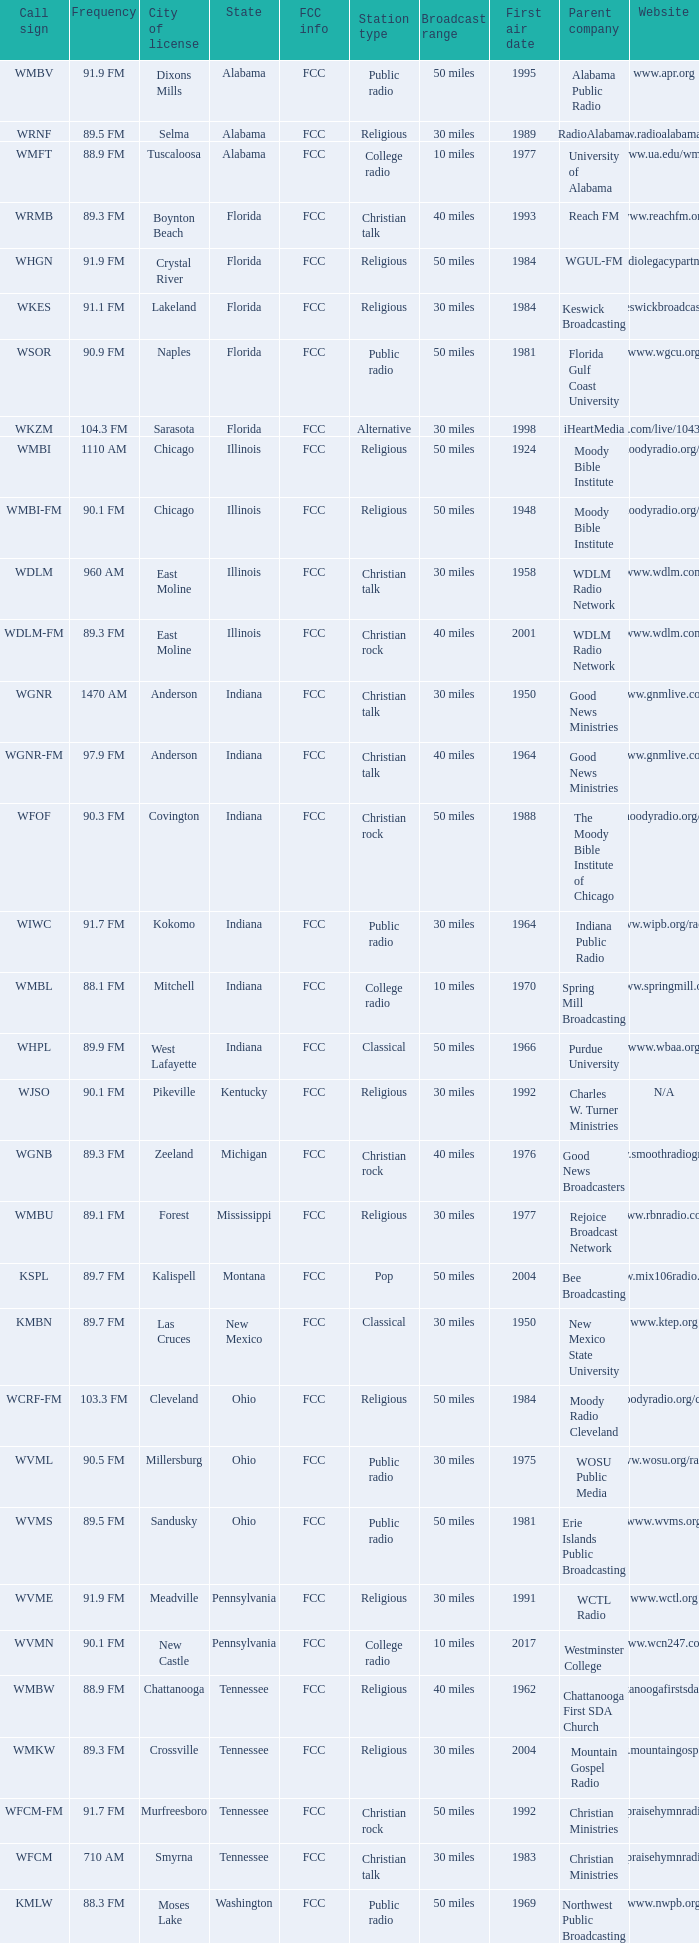Can you give me the fcc details for the west lafayette, indiana radio station? FCC. 